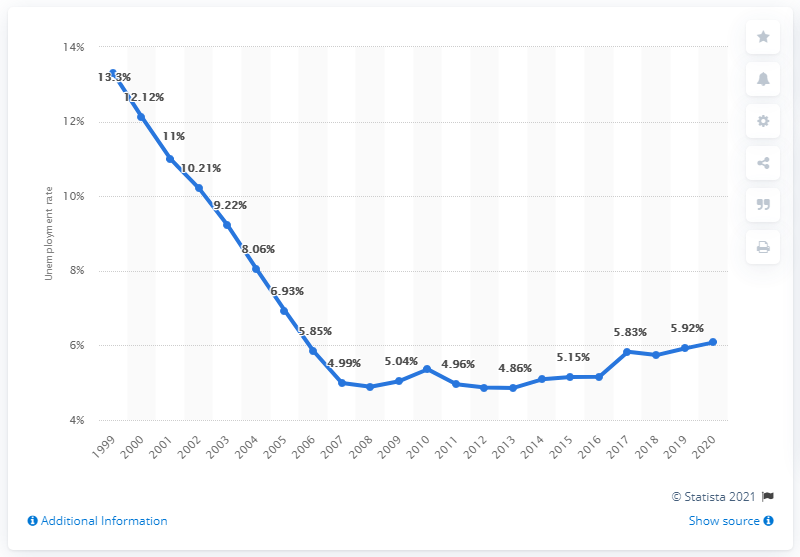Indicate a few pertinent items in this graphic. In 2020, the unemployment rate in Uzbekistan was 6.08%. 